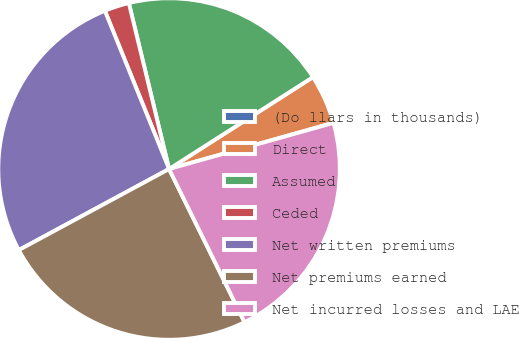Convert chart to OTSL. <chart><loc_0><loc_0><loc_500><loc_500><pie_chart><fcel>(Do llars in thousands)<fcel>Direct<fcel>Assumed<fcel>Ceded<fcel>Net written premiums<fcel>Net premiums earned<fcel>Net incurred losses and LAE<nl><fcel>0.01%<fcel>4.68%<fcel>19.74%<fcel>2.35%<fcel>26.74%<fcel>24.41%<fcel>22.07%<nl></chart> 